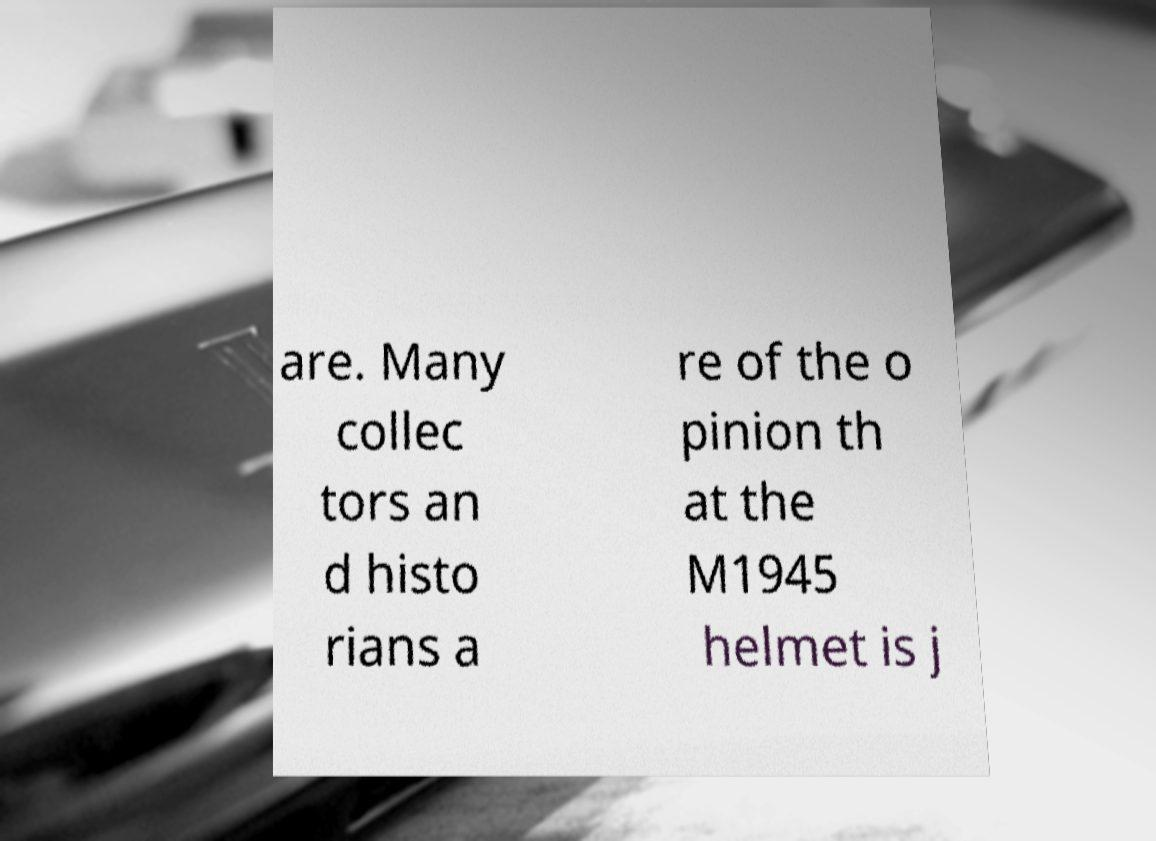Can you accurately transcribe the text from the provided image for me? are. Many collec tors an d histo rians a re of the o pinion th at the M1945 helmet is j 